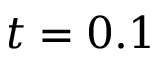Convert formula to latex. <formula><loc_0><loc_0><loc_500><loc_500>t = 0 . 1</formula> 